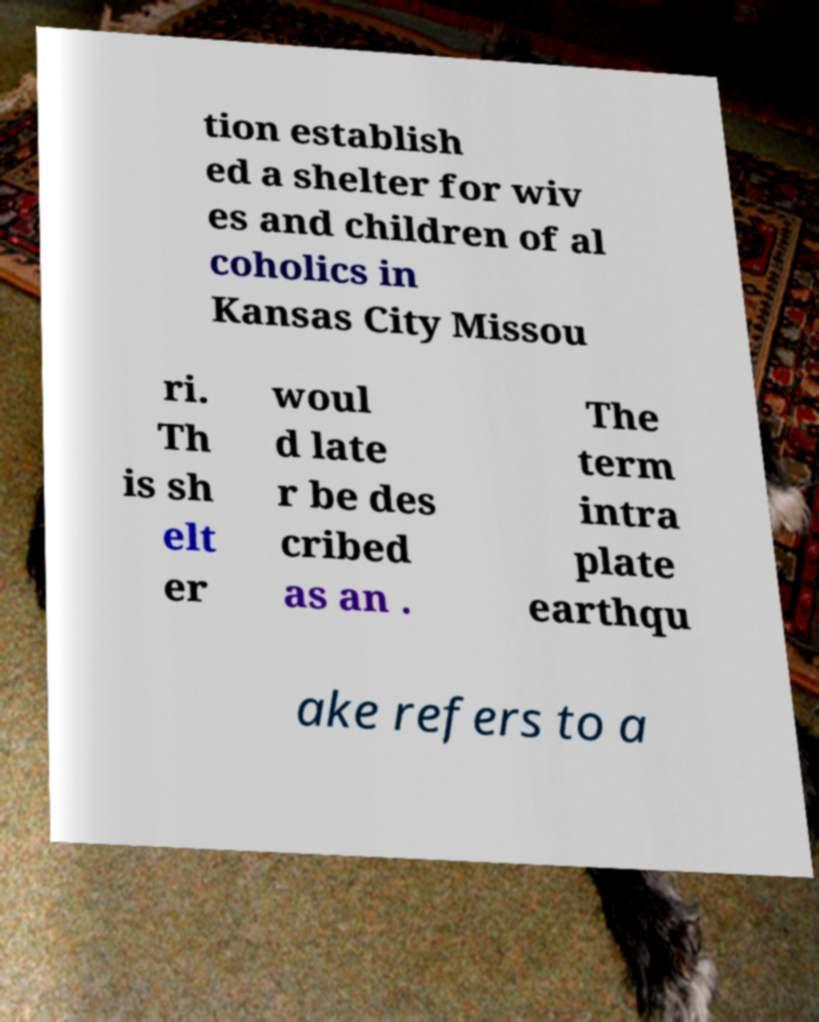Can you read and provide the text displayed in the image?This photo seems to have some interesting text. Can you extract and type it out for me? tion establish ed a shelter for wiv es and children of al coholics in Kansas City Missou ri. Th is sh elt er woul d late r be des cribed as an . The term intra plate earthqu ake refers to a 